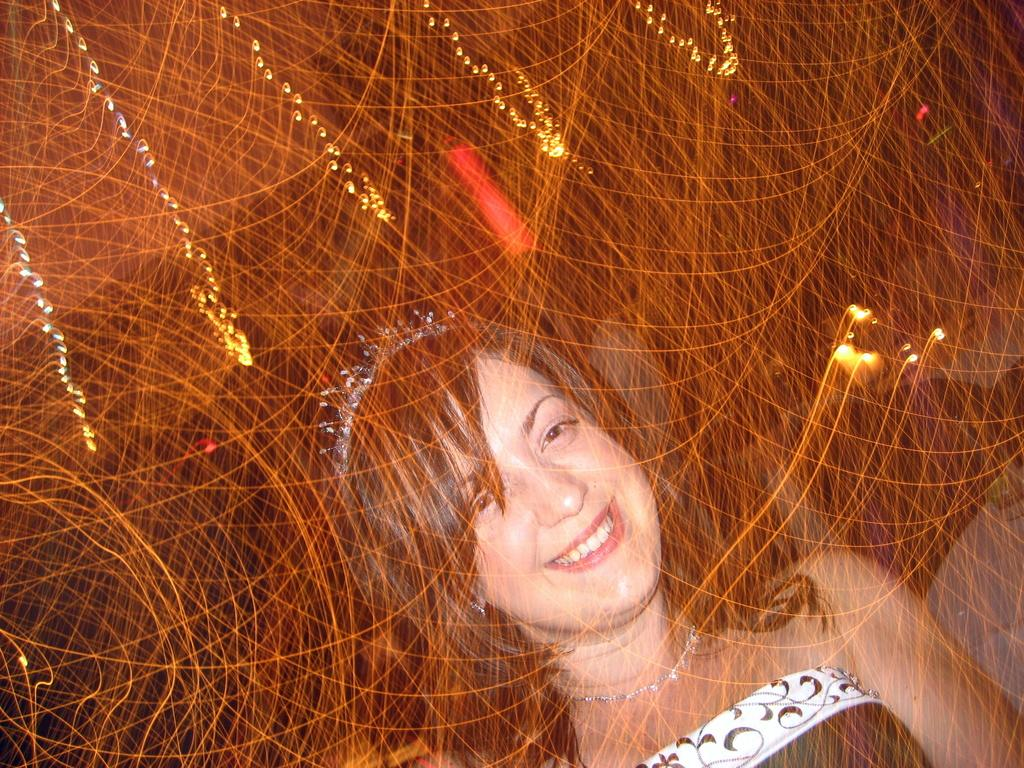Who is present in the image? There is a woman in the image. Where is the woman located in the image? The woman is at the bottom of the image. What type of lighting is present in the image? There are LED lights in the image. Where are the LED lights located in the image? The LED lights are at the top of the image. What can be inferred about the lighting conditions in the image? The background of the image is dark. What type of government is depicted in the image? There is no depiction of a government in the image; it features a woman and LED lights. What brand of soda is being consumed by the woman in the image? There is no soda present in the image; it only shows a woman and LED lights. 